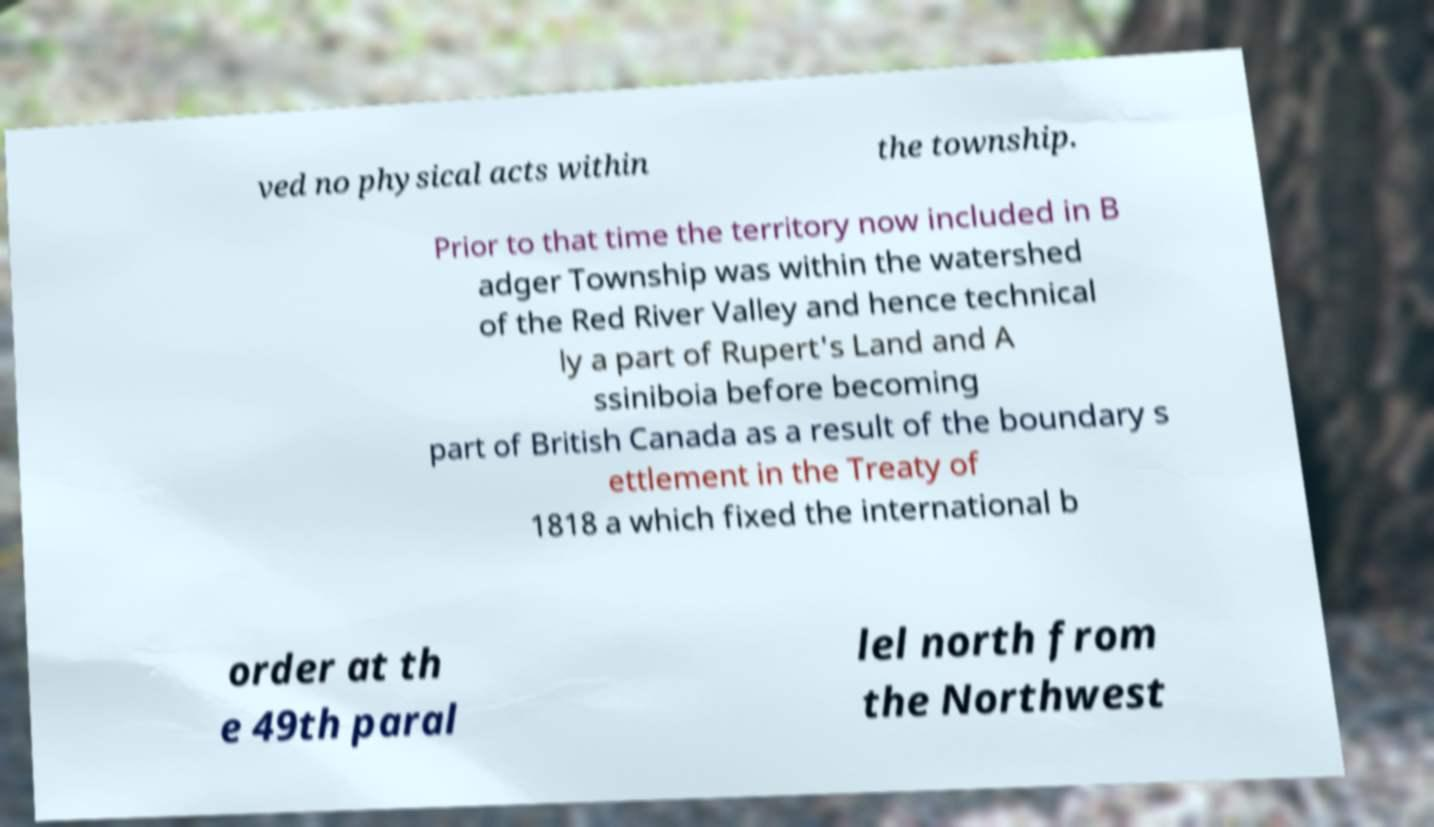There's text embedded in this image that I need extracted. Can you transcribe it verbatim? ved no physical acts within the township. Prior to that time the territory now included in B adger Township was within the watershed of the Red River Valley and hence technical ly a part of Rupert's Land and A ssiniboia before becoming part of British Canada as a result of the boundary s ettlement in the Treaty of 1818 a which fixed the international b order at th e 49th paral lel north from the Northwest 